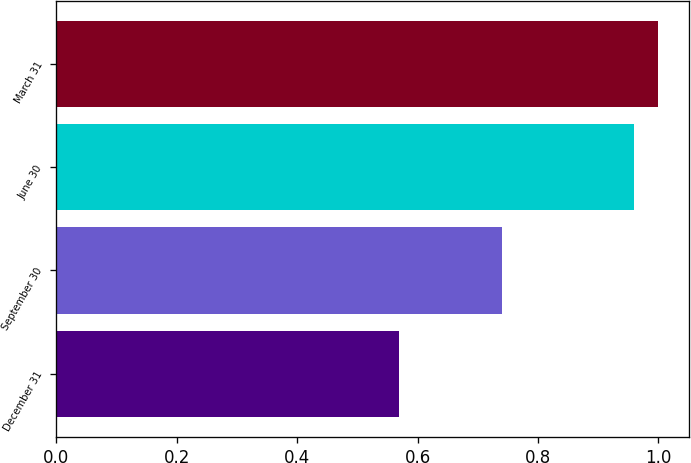<chart> <loc_0><loc_0><loc_500><loc_500><bar_chart><fcel>December 31<fcel>September 30<fcel>June 30<fcel>March 31<nl><fcel>0.57<fcel>0.74<fcel>0.96<fcel>1<nl></chart> 